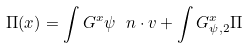<formula> <loc_0><loc_0><loc_500><loc_500>\Pi ( x ) = \int G ^ { x } \psi \ n \cdot v + \int G ^ { x } _ { \psi , 2 } \Pi</formula> 